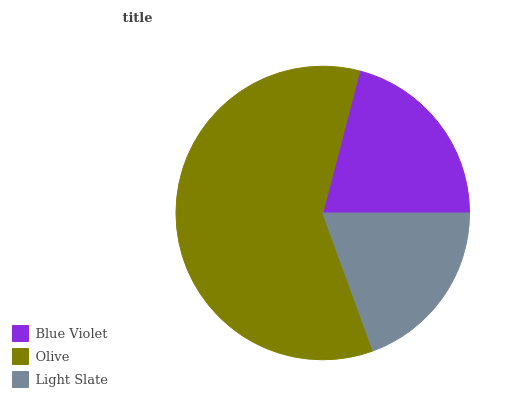Is Light Slate the minimum?
Answer yes or no. Yes. Is Olive the maximum?
Answer yes or no. Yes. Is Olive the minimum?
Answer yes or no. No. Is Light Slate the maximum?
Answer yes or no. No. Is Olive greater than Light Slate?
Answer yes or no. Yes. Is Light Slate less than Olive?
Answer yes or no. Yes. Is Light Slate greater than Olive?
Answer yes or no. No. Is Olive less than Light Slate?
Answer yes or no. No. Is Blue Violet the high median?
Answer yes or no. Yes. Is Blue Violet the low median?
Answer yes or no. Yes. Is Olive the high median?
Answer yes or no. No. Is Olive the low median?
Answer yes or no. No. 